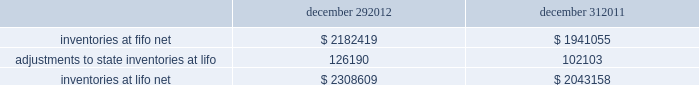In june 2011 , the fasb issued asu no .
2011-05 201ccomprehensive income 2013 presentation of comprehensive income . 201d asu 2011-05 requires comprehensive income , the components of net income , and the components of other comprehensive income either in a single continuous statement of comprehensive income or in two separate but consecutive statements .
In both choices , an entity is required to present each component of net income along with total net income , each component of other comprehensive income along with a total for other comprehensive income , and a total amount for comprehensive income .
This update eliminates the option to present the components of other comprehensive income as part of the statement of changes in stockholders' equity .
The amendments in this update do not change the items that must be reported in other comprehensive income or when an item of other comprehensive income must be reclassified to net income .
The amendments in this update should be applied retrospectively and is effective for interim and annual reporting periods beginning after december 15 , 2011 .
The company adopted this guidance in the first quarter of 2012 .
The adoption of asu 2011-05 is for presentation purposes only and had no material impact on the company 2019s consolidated financial statements .
Inventories , net : merchandise inventory the company used the lifo method of accounting for approximately 95% ( 95 % ) of inventories at both december 29 , 2012 and december 31 , 2011 .
Under lifo , the company 2019s cost of sales reflects the costs of the most recently purchased inventories , while the inventory carrying balance represents the costs for inventories purchased in fiscal 2012 and prior years .
The company recorded a reduction to cost of sales of $ 24087 and $ 29554 in fiscal 2012 and fiscal 2010 , respectively .
As a result of utilizing lifo , the company recorded an increase to cost of sales of $ 24708 for fiscal 2011 , due to an increase in supply chain costs and inflationary pressures affecting certain product categories .
The company 2019s overall costs to acquire inventory for the same or similar products have generally decreased historically as the company has been able to leverage its continued growth , execution of merchandise strategies and realization of supply chain efficiencies .
Product cores the remaining inventories are comprised of product cores , the non-consumable portion of certain parts and batteries , which are valued under the first-in , first-out ( "fifo" ) method .
Product cores are included as part of the company's merchandise costs and are either passed on to the customer or returned to the vendor .
Because product cores are not subject to frequent cost changes like the company's other merchandise inventory , there is no material difference when applying either the lifo or fifo valuation method .
Inventory overhead costs purchasing and warehousing costs included in inventory at december 29 , 2012 and december 31 , 2011 , were $ 134258 and $ 126840 , respectively .
Inventory balance and inventory reserves inventory balances at the end of fiscal 2012 and 2011 were as follows : december 29 , december 31 .
Inventory quantities are tracked through a perpetual inventory system .
The company completes physical inventories and other targeted inventory counts in its store locations to ensure the accuracy of the perpetual inventory quantities of both merchandise and core inventory in these locations .
In its distribution centers and pdq aes , the company uses a cycle counting program to ensure the accuracy of the perpetual inventory quantities of both merchandise and product core inventory .
Reserves advance auto parts , inc .
And subsidiaries notes to the consolidated financial statements december 29 , 2012 , december 31 , 2011 and january 1 , 2011 ( in thousands , except per share data ) .
What is the percentage change in inventories at fifo net during 2012? 
Computations: ((2182419 - 1941055) / 1941055)
Answer: 0.12435. 